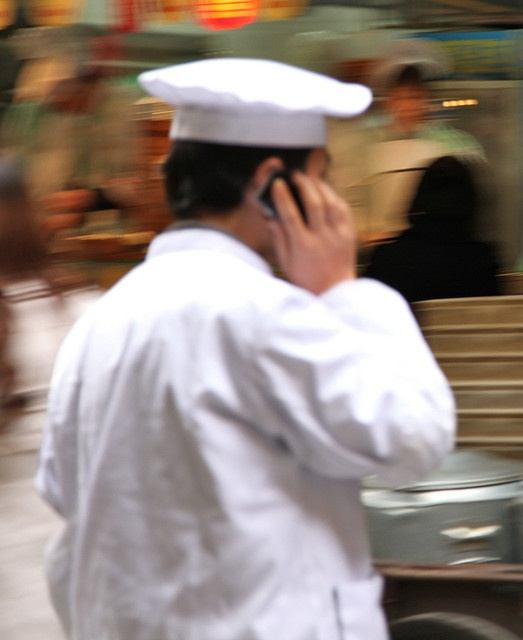Describe the objects in this image and their specific colors. I can see people in orange, lavender, darkgray, gray, and black tones, people in orange, black, tan, olive, and brown tones, and cell phone in orange, black, brown, and maroon tones in this image. 